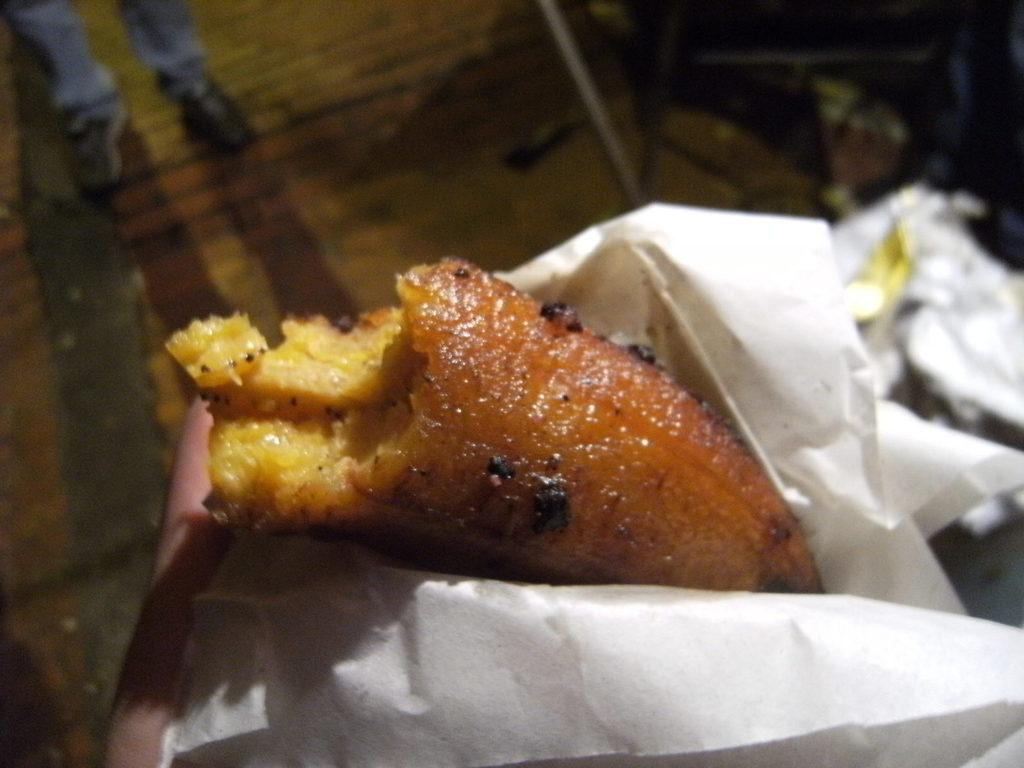What is the person's hand holding in the image? The person's hand is holding a food item in the image. How is the food item covered in the image? The food item is covered with a paper in the image. Can you describe the background of the image? The background of the image is blurred. What theory is being discussed at the desk in the image? There is no desk or discussion of a theory present in the image. What type of mint is visible in the image? There is no mint present in the image. 